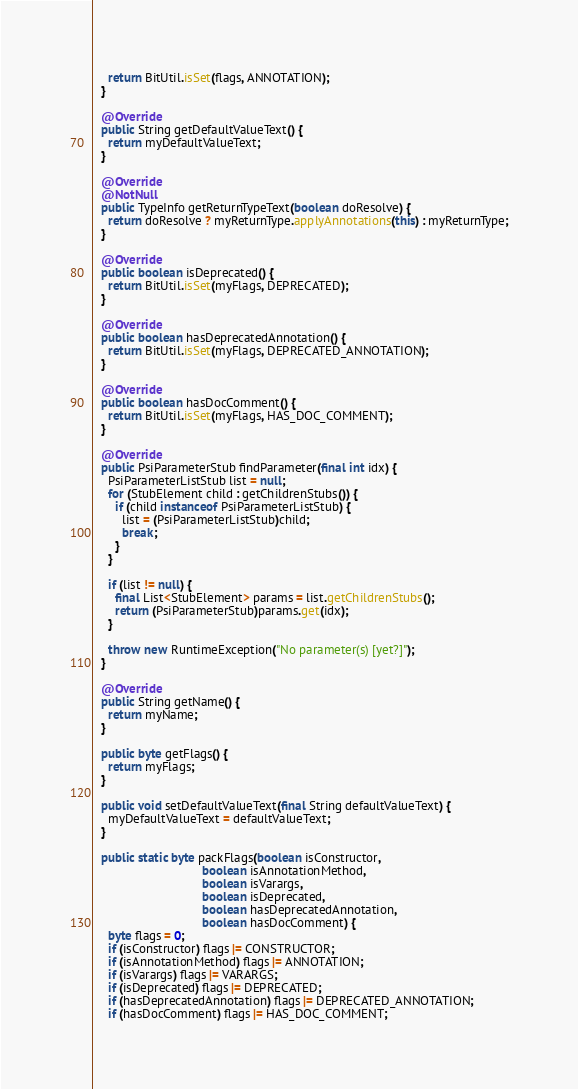<code> <loc_0><loc_0><loc_500><loc_500><_Java_>    return BitUtil.isSet(flags, ANNOTATION);
  }

  @Override
  public String getDefaultValueText() {
    return myDefaultValueText;
  }

  @Override
  @NotNull
  public TypeInfo getReturnTypeText(boolean doResolve) {
    return doResolve ? myReturnType.applyAnnotations(this) : myReturnType;
  }

  @Override
  public boolean isDeprecated() {
    return BitUtil.isSet(myFlags, DEPRECATED);
  }

  @Override
  public boolean hasDeprecatedAnnotation() {
    return BitUtil.isSet(myFlags, DEPRECATED_ANNOTATION);
  }

  @Override
  public boolean hasDocComment() {
    return BitUtil.isSet(myFlags, HAS_DOC_COMMENT);
  }

  @Override
  public PsiParameterStub findParameter(final int idx) {
    PsiParameterListStub list = null;
    for (StubElement child : getChildrenStubs()) {
      if (child instanceof PsiParameterListStub) {
        list = (PsiParameterListStub)child;
        break;
      }
    }

    if (list != null) {
      final List<StubElement> params = list.getChildrenStubs();
      return (PsiParameterStub)params.get(idx);
    }

    throw new RuntimeException("No parameter(s) [yet?]");
  }

  @Override
  public String getName() {
    return myName;
  }

  public byte getFlags() {
    return myFlags;
  }

  public void setDefaultValueText(final String defaultValueText) {
    myDefaultValueText = defaultValueText;
  }

  public static byte packFlags(boolean isConstructor,
                               boolean isAnnotationMethod,
                               boolean isVarargs,
                               boolean isDeprecated,
                               boolean hasDeprecatedAnnotation,
                               boolean hasDocComment) {
    byte flags = 0;
    if (isConstructor) flags |= CONSTRUCTOR;
    if (isAnnotationMethod) flags |= ANNOTATION;
    if (isVarargs) flags |= VARARGS;
    if (isDeprecated) flags |= DEPRECATED;
    if (hasDeprecatedAnnotation) flags |= DEPRECATED_ANNOTATION;
    if (hasDocComment) flags |= HAS_DOC_COMMENT;</code> 